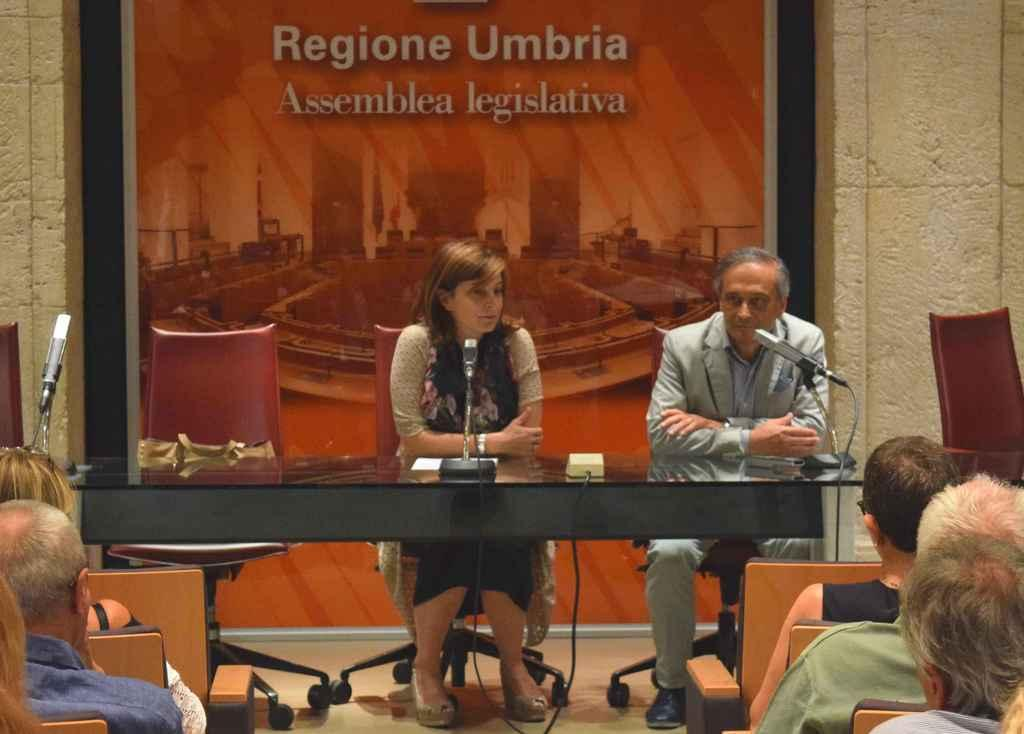What are the people in the image doing? There are people sitting on chairs in the image. Can you describe the positions of the people in the image? There is a woman sitting in front of a mic, and a man is also sitting in front of a mic. What might be the purpose of the mics in the image? The mics in the image might be used for recording or broadcasting. Can you see any fairies flying around the people in the image? No, there are no fairies present in the image. What type of toothbrush is the man using in the image? There is no toothbrush visible in the image. 